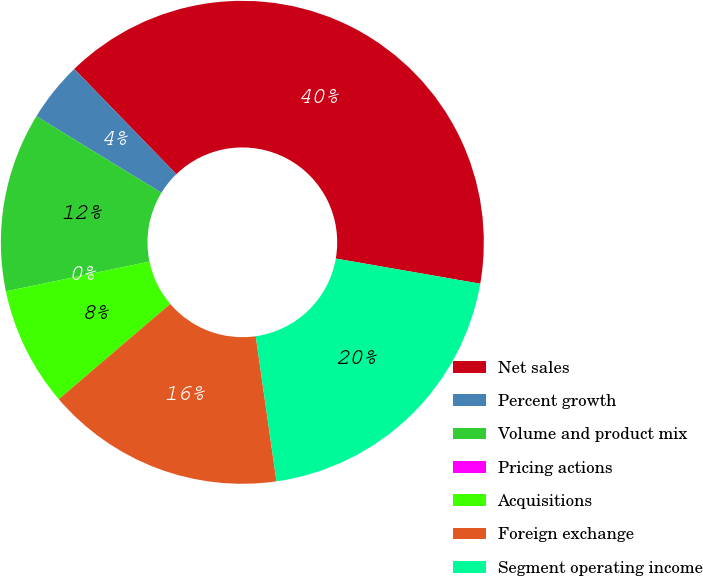<chart> <loc_0><loc_0><loc_500><loc_500><pie_chart><fcel>Net sales<fcel>Percent growth<fcel>Volume and product mix<fcel>Pricing actions<fcel>Acquisitions<fcel>Foreign exchange<fcel>Segment operating income<nl><fcel>40.0%<fcel>4.0%<fcel>12.0%<fcel>0.0%<fcel>8.0%<fcel>16.0%<fcel>20.0%<nl></chart> 